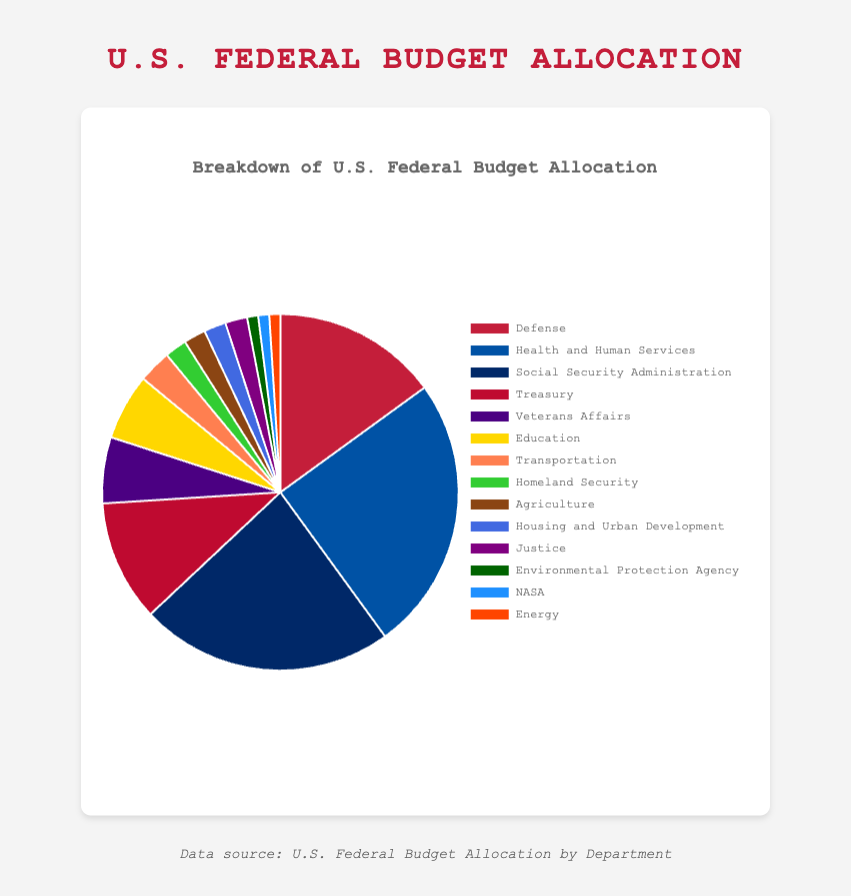Which department has the highest allocation percentage? By looking at the pie chart, we see that the Health and Human Services department has the largest segment. The legend confirms that Health and Human Services receives 25% of the budget.
Answer: Health and Human Services What is the combined allocation percentage for the Defense and Veterans Affairs departments? Add the percentages for Defense (15%) and Veterans Affairs (6%). The total is 15 + 6 = 21%.
Answer: 21% Which department receives a higher allocation, Education or Transportation? Compare the segments for Education and Transportation visually. Education has a larger segment than Transportation. The legend confirms Education receives 6%, while Transportation gets 3%.
Answer: Education What percentage of the budget is allocated to the Treasury? Refer to the legend and find the Treasury department's allocation. It shows 11%.
Answer: 11% How much more is allocated to Social Security Administration compared to Agriculture? Subtract the percentage for Agriculture (2%) from the percentage for Social Security Administration (23%). The difference is 23 - 2 = 21%.
Answer: 21% Which departments have an equal allocation of 2%? Identify the departments with segments and associated percentages equal to 2% from the legend. The departments are Homeland Security, Agriculture, Housing and Urban Development, and Justice.
Answer: Homeland Security, Agriculture, Housing and Urban Development, Justice What is the total percentage allocated to departments that each receive 1%? Add the percentages of the departments that receive 1%: Environmental Protection Agency (1%), NASA (1%), and Energy (1%). The total is 1 + 1 + 1 = 3%.
Answer: 3% What is the percentage gap between Health and Human Services and Defense? Subtract the percentage for Defense (15%) from the percentage for Health and Human Services (25%). The gap is 25 - 15 = 10%.
Answer: 10% Which department has the smallest allocation percentage? Identify the smallest segment in the pie chart, which corresponds to the smallest percentage. The legend confirms that Environmental Protection Agency, NASA, and Energy each have the smallest allocation of 1%.
Answer: Environmental Protection Agency, NASA, Energy How much of the budget is allocated to non-defense departments (exclude Defense)? Sum the percentages allocated to all departments except Defense: Health and Human Services (25%), Social Security Administration (23%), Treasury (11%), Veterans Affairs (6%), Education (6%), Transportation (3%), Homeland Security (2%), Agriculture (2%), Housing and Urban Development (2%), Justice (2%), Environmental Protection Agency (1%), NASA (1%), and Energy (1%). The combined percentage is 25 + 23 + 11 + 6 + 6 + 3 + 2 + 2 + 2 + 2 + 1 + 1 + 1 = 85%.
Answer: 85% 